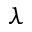<formula> <loc_0><loc_0><loc_500><loc_500>\lambda</formula> 